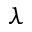<formula> <loc_0><loc_0><loc_500><loc_500>\lambda</formula> 